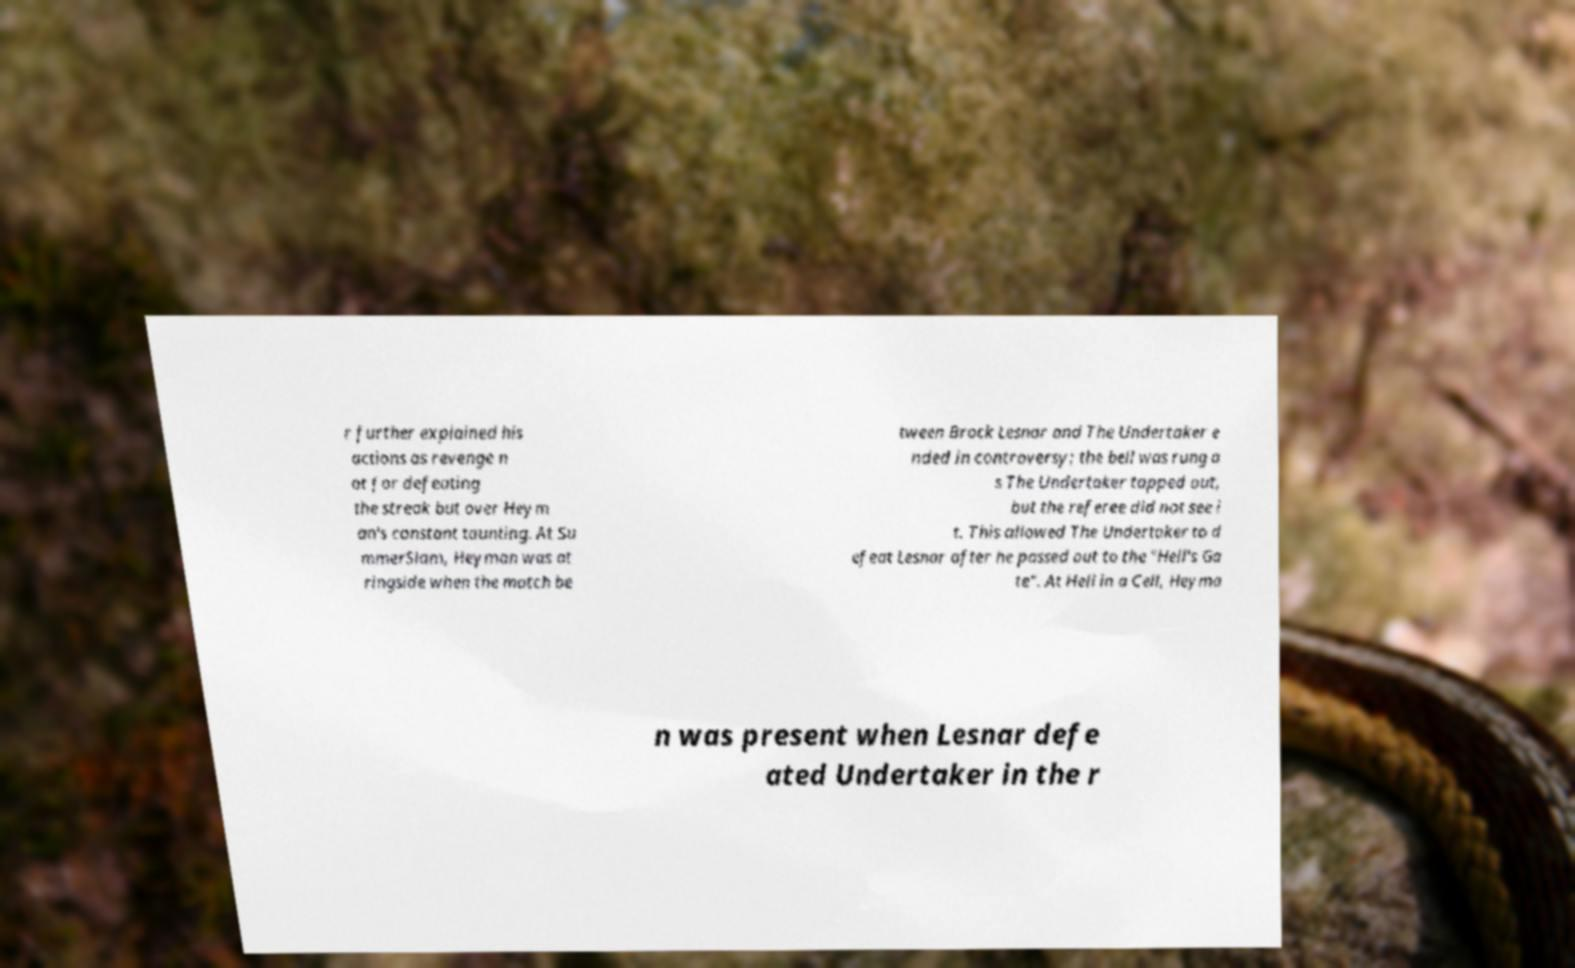Could you extract and type out the text from this image? r further explained his actions as revenge n ot for defeating the streak but over Heym an's constant taunting. At Su mmerSlam, Heyman was at ringside when the match be tween Brock Lesnar and The Undertaker e nded in controversy; the bell was rung a s The Undertaker tapped out, but the referee did not see i t. This allowed The Undertaker to d efeat Lesnar after he passed out to the "Hell's Ga te". At Hell in a Cell, Heyma n was present when Lesnar defe ated Undertaker in the r 